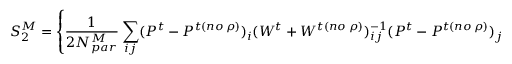Convert formula to latex. <formula><loc_0><loc_0><loc_500><loc_500>S _ { 2 } ^ { M } = \left \{ { \frac { 1 } { 2 N _ { p a r } ^ { M } } } \sum _ { i j } ( P ^ { t } - P ^ { t ( n o \, \rho ) } ) _ { i } ( W ^ { t } + W ^ { t ( n o \, \rho ) } ) _ { i j } ^ { - 1 } ( P ^ { t } - P ^ { t ( n o \, \rho ) } ) _ { j } \right \} ^ { - 1 } .</formula> 